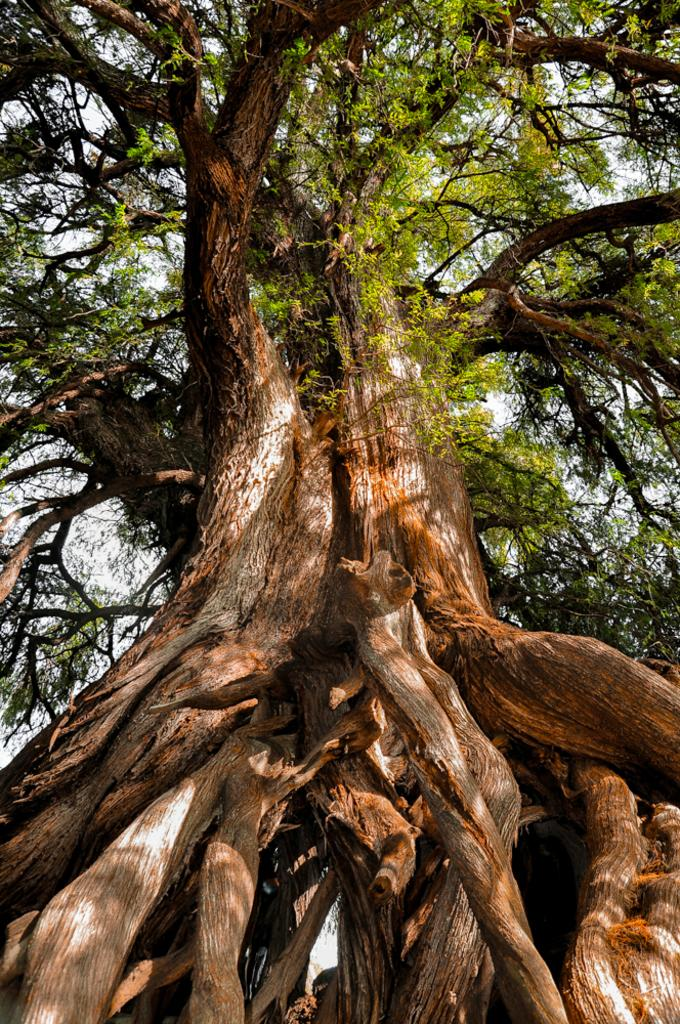What type of vegetation is in the middle of the image? There are trees in the middle of the image. What is visible at the top of the image? The sky is visible at the top of the image. What direction is the wave coming from in the image? There is no wave present in the image. What type of utensil is used to stir the trees in the image? There are no utensils or stirring involved with the trees in the image; they are stationary. 